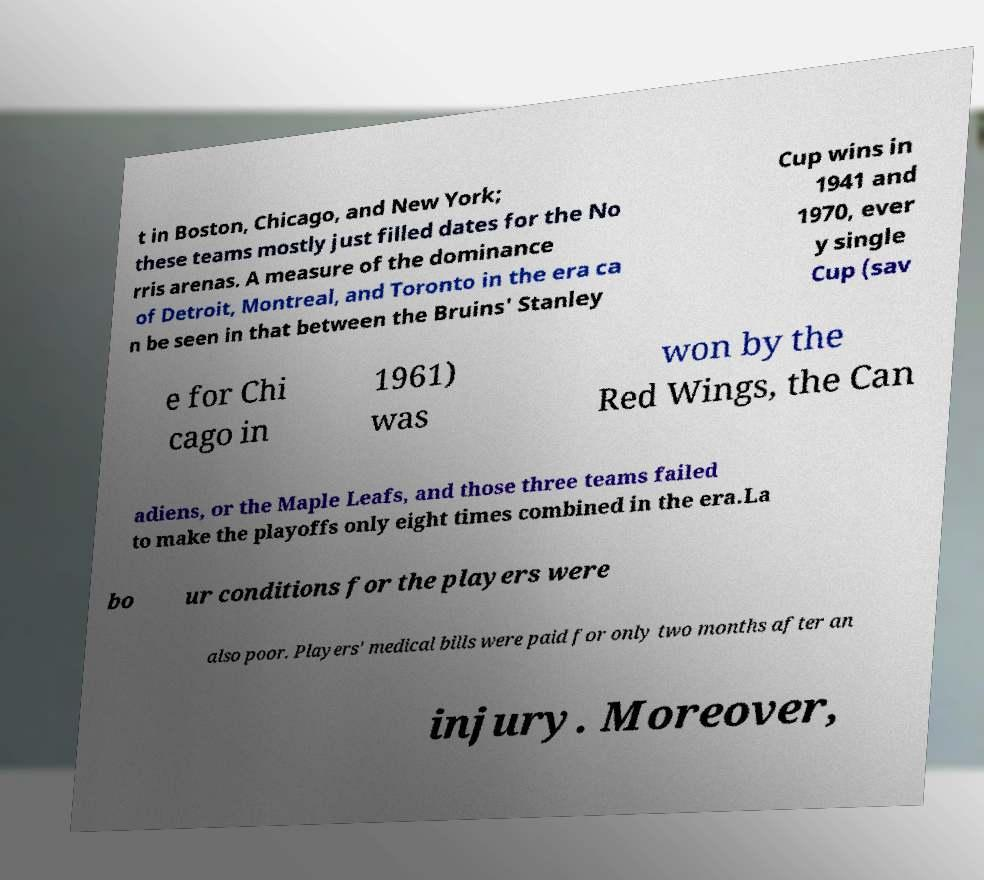Please read and relay the text visible in this image. What does it say? t in Boston, Chicago, and New York; these teams mostly just filled dates for the No rris arenas. A measure of the dominance of Detroit, Montreal, and Toronto in the era ca n be seen in that between the Bruins' Stanley Cup wins in 1941 and 1970, ever y single Cup (sav e for Chi cago in 1961) was won by the Red Wings, the Can adiens, or the Maple Leafs, and those three teams failed to make the playoffs only eight times combined in the era.La bo ur conditions for the players were also poor. Players' medical bills were paid for only two months after an injury. Moreover, 